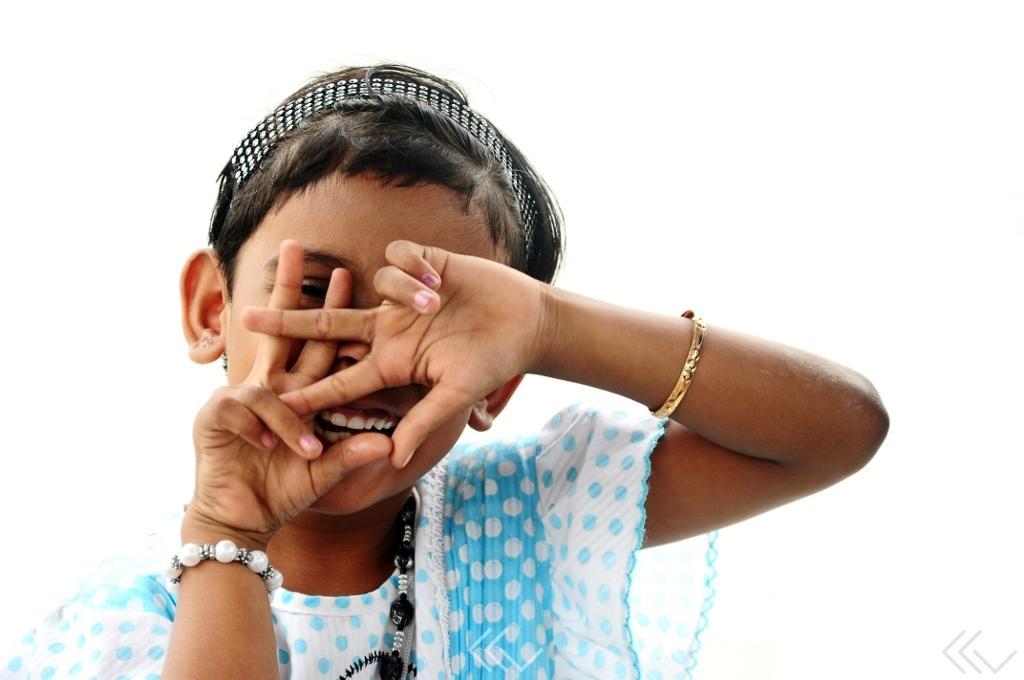Please provide a concise description of this image. In this image there is a girl smiling. 